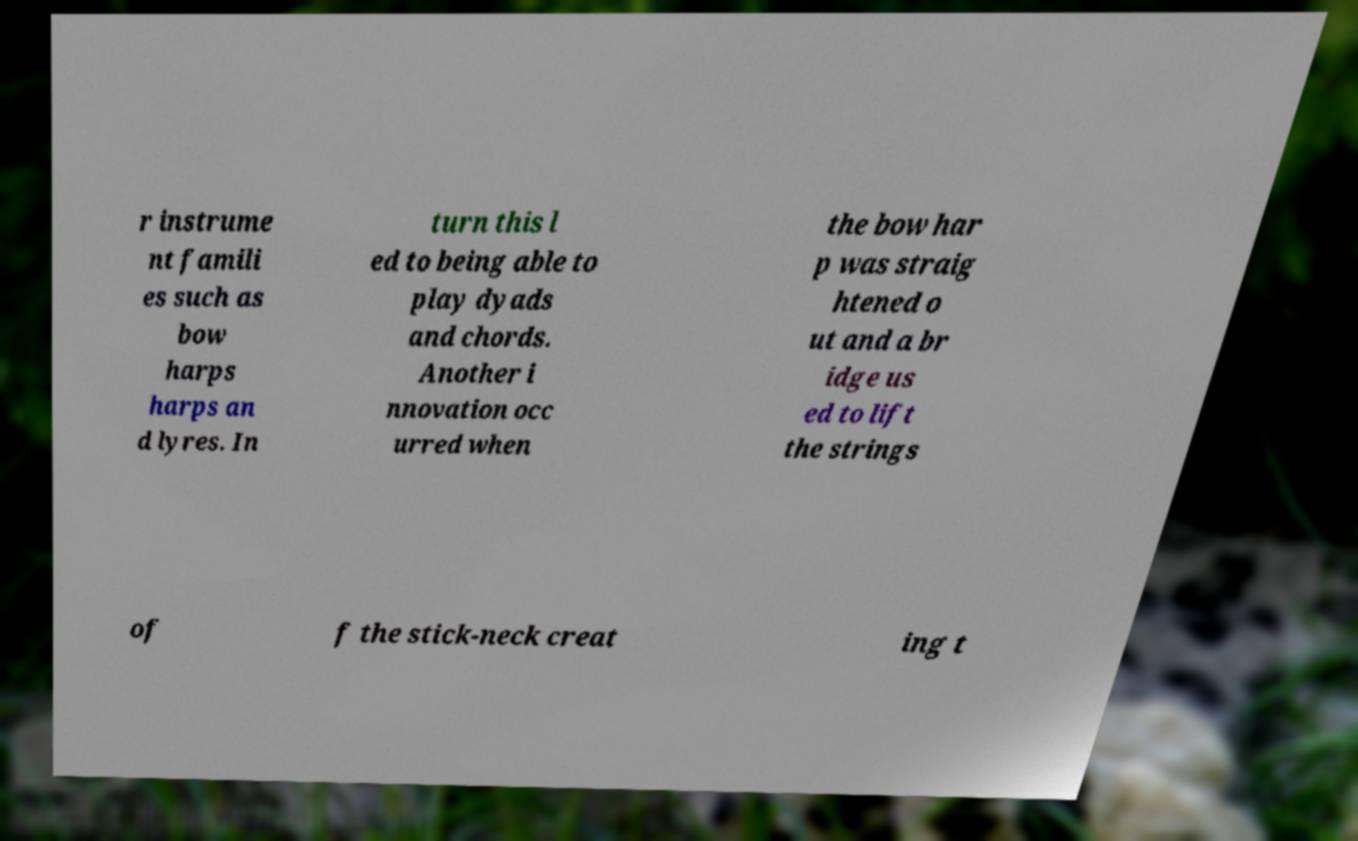Please identify and transcribe the text found in this image. r instrume nt famili es such as bow harps harps an d lyres. In turn this l ed to being able to play dyads and chords. Another i nnovation occ urred when the bow har p was straig htened o ut and a br idge us ed to lift the strings of f the stick-neck creat ing t 